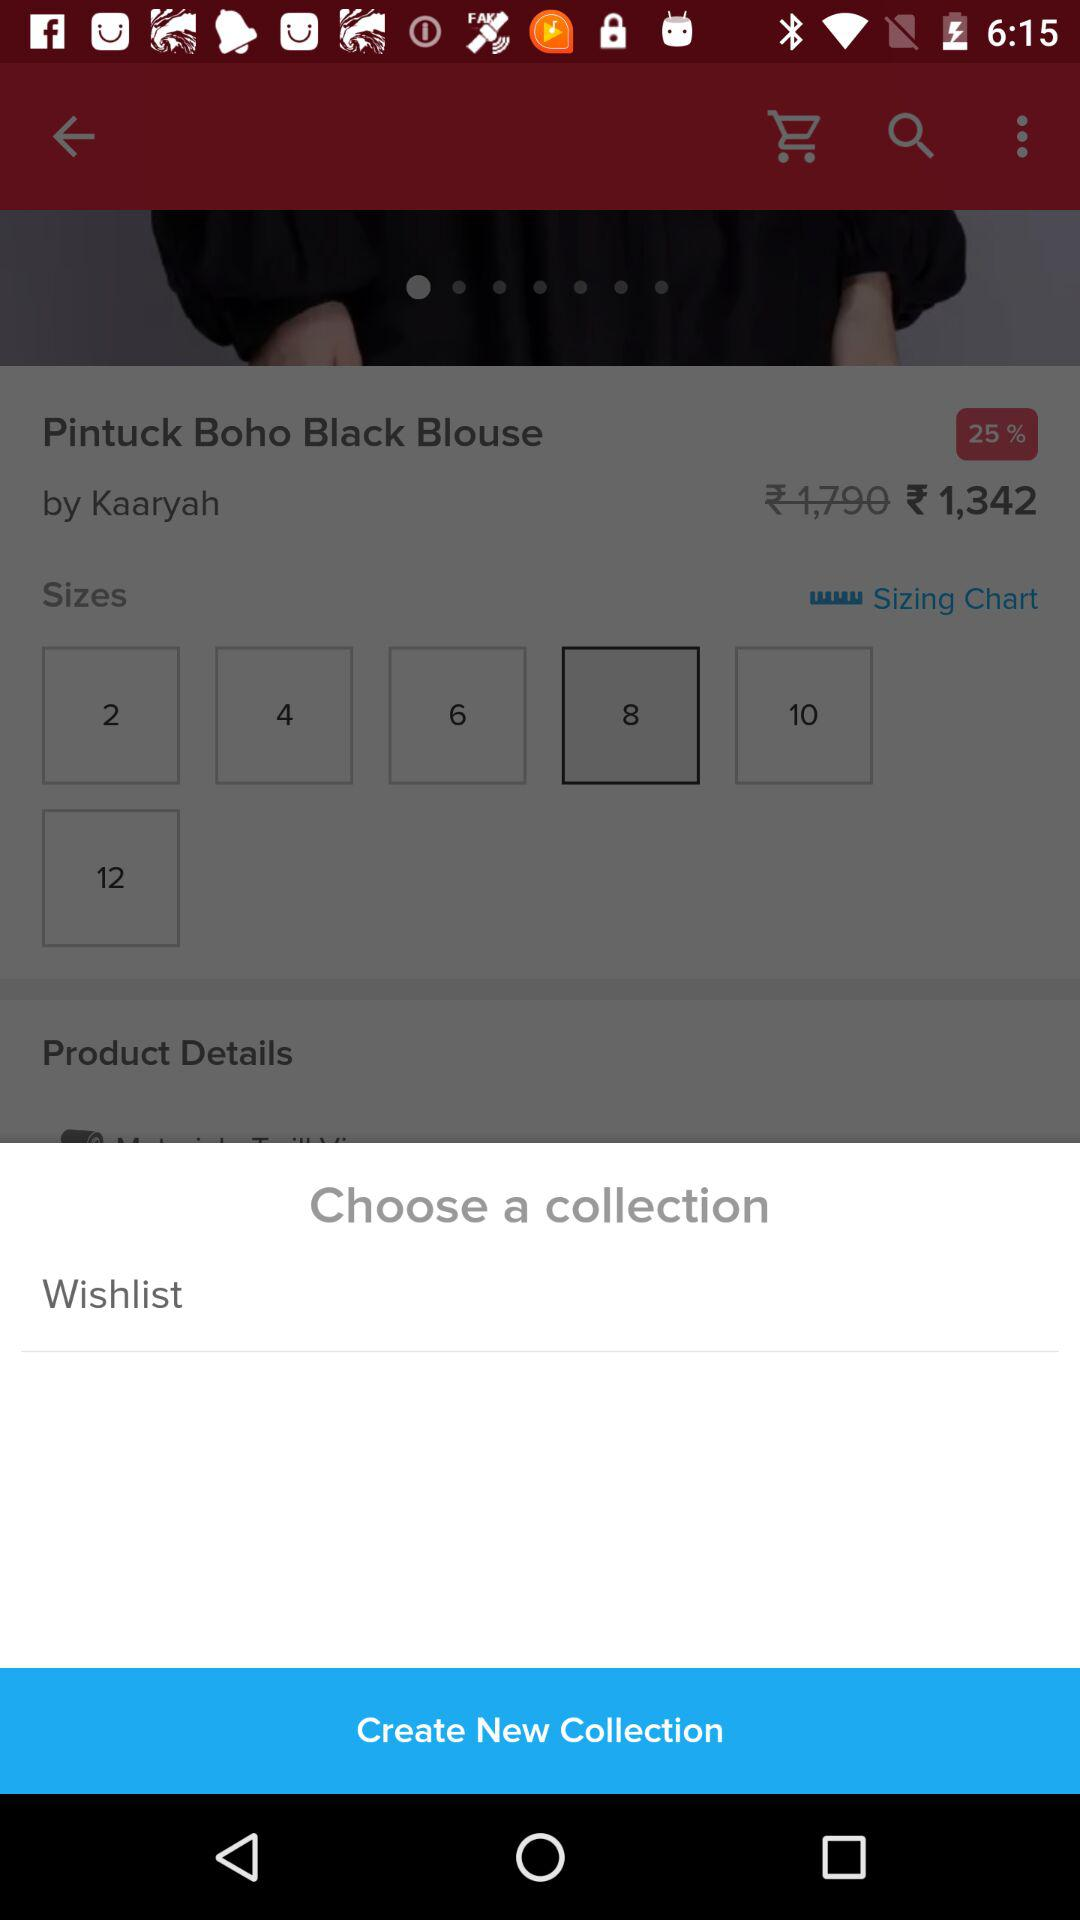Which size is selected? The selected size is 8. 